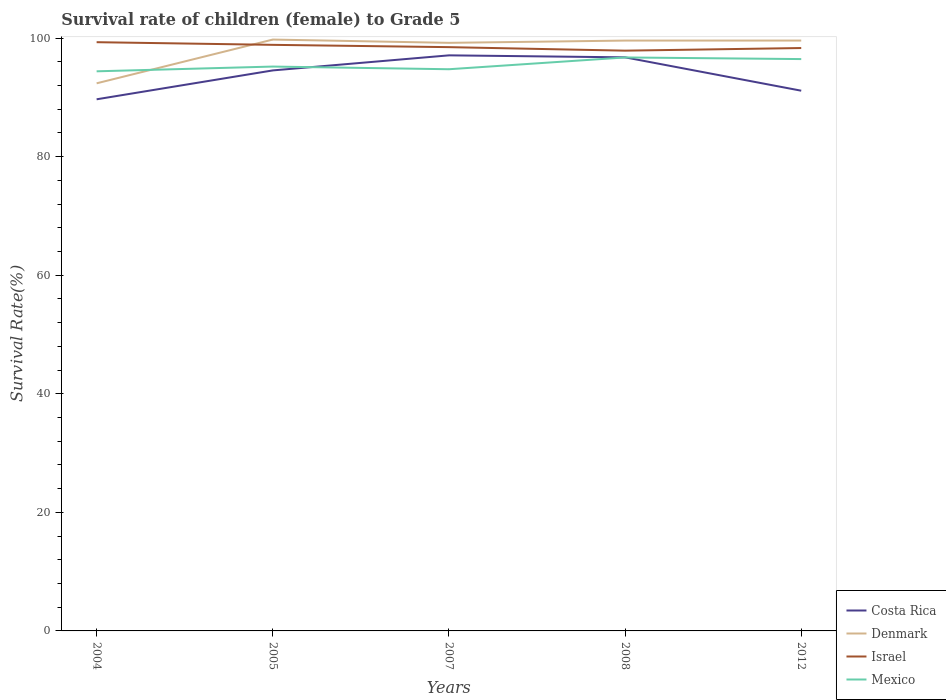How many different coloured lines are there?
Your answer should be compact. 4. Across all years, what is the maximum survival rate of female children to grade 5 in Israel?
Your response must be concise. 97.89. What is the total survival rate of female children to grade 5 in Israel in the graph?
Offer a very short reply. 0.59. What is the difference between the highest and the second highest survival rate of female children to grade 5 in Mexico?
Offer a terse response. 2.34. What is the difference between the highest and the lowest survival rate of female children to grade 5 in Costa Rica?
Give a very brief answer. 3. Is the survival rate of female children to grade 5 in Denmark strictly greater than the survival rate of female children to grade 5 in Costa Rica over the years?
Give a very brief answer. No. What is the difference between two consecutive major ticks on the Y-axis?
Your response must be concise. 20. Are the values on the major ticks of Y-axis written in scientific E-notation?
Make the answer very short. No. Does the graph contain any zero values?
Your response must be concise. No. Where does the legend appear in the graph?
Your answer should be very brief. Bottom right. How are the legend labels stacked?
Make the answer very short. Vertical. What is the title of the graph?
Your response must be concise. Survival rate of children (female) to Grade 5. Does "Uganda" appear as one of the legend labels in the graph?
Offer a terse response. No. What is the label or title of the X-axis?
Your response must be concise. Years. What is the label or title of the Y-axis?
Your answer should be compact. Survival Rate(%). What is the Survival Rate(%) of Costa Rica in 2004?
Provide a short and direct response. 89.68. What is the Survival Rate(%) in Denmark in 2004?
Give a very brief answer. 92.38. What is the Survival Rate(%) in Israel in 2004?
Your answer should be very brief. 99.31. What is the Survival Rate(%) in Mexico in 2004?
Your answer should be compact. 94.4. What is the Survival Rate(%) in Costa Rica in 2005?
Offer a very short reply. 94.55. What is the Survival Rate(%) in Denmark in 2005?
Keep it short and to the point. 99.76. What is the Survival Rate(%) of Israel in 2005?
Keep it short and to the point. 98.87. What is the Survival Rate(%) of Mexico in 2005?
Give a very brief answer. 95.2. What is the Survival Rate(%) in Costa Rica in 2007?
Give a very brief answer. 97.09. What is the Survival Rate(%) in Denmark in 2007?
Your answer should be very brief. 99.2. What is the Survival Rate(%) in Israel in 2007?
Your answer should be compact. 98.48. What is the Survival Rate(%) in Mexico in 2007?
Offer a terse response. 94.75. What is the Survival Rate(%) in Costa Rica in 2008?
Your answer should be very brief. 96.76. What is the Survival Rate(%) of Denmark in 2008?
Keep it short and to the point. 99.59. What is the Survival Rate(%) of Israel in 2008?
Provide a short and direct response. 97.89. What is the Survival Rate(%) of Mexico in 2008?
Keep it short and to the point. 96.74. What is the Survival Rate(%) in Costa Rica in 2012?
Offer a terse response. 91.13. What is the Survival Rate(%) of Denmark in 2012?
Your answer should be very brief. 99.59. What is the Survival Rate(%) in Israel in 2012?
Offer a terse response. 98.33. What is the Survival Rate(%) in Mexico in 2012?
Keep it short and to the point. 96.47. Across all years, what is the maximum Survival Rate(%) of Costa Rica?
Your answer should be very brief. 97.09. Across all years, what is the maximum Survival Rate(%) of Denmark?
Make the answer very short. 99.76. Across all years, what is the maximum Survival Rate(%) of Israel?
Give a very brief answer. 99.31. Across all years, what is the maximum Survival Rate(%) in Mexico?
Make the answer very short. 96.74. Across all years, what is the minimum Survival Rate(%) in Costa Rica?
Make the answer very short. 89.68. Across all years, what is the minimum Survival Rate(%) in Denmark?
Give a very brief answer. 92.38. Across all years, what is the minimum Survival Rate(%) in Israel?
Offer a very short reply. 97.89. Across all years, what is the minimum Survival Rate(%) of Mexico?
Your answer should be compact. 94.4. What is the total Survival Rate(%) in Costa Rica in the graph?
Provide a short and direct response. 469.22. What is the total Survival Rate(%) in Denmark in the graph?
Make the answer very short. 490.51. What is the total Survival Rate(%) of Israel in the graph?
Offer a terse response. 492.88. What is the total Survival Rate(%) of Mexico in the graph?
Ensure brevity in your answer.  477.56. What is the difference between the Survival Rate(%) of Costa Rica in 2004 and that in 2005?
Ensure brevity in your answer.  -4.87. What is the difference between the Survival Rate(%) in Denmark in 2004 and that in 2005?
Your answer should be very brief. -7.38. What is the difference between the Survival Rate(%) of Israel in 2004 and that in 2005?
Ensure brevity in your answer.  0.45. What is the difference between the Survival Rate(%) in Mexico in 2004 and that in 2005?
Give a very brief answer. -0.8. What is the difference between the Survival Rate(%) of Costa Rica in 2004 and that in 2007?
Make the answer very short. -7.41. What is the difference between the Survival Rate(%) in Denmark in 2004 and that in 2007?
Offer a very short reply. -6.83. What is the difference between the Survival Rate(%) of Israel in 2004 and that in 2007?
Give a very brief answer. 0.83. What is the difference between the Survival Rate(%) of Mexico in 2004 and that in 2007?
Provide a succinct answer. -0.35. What is the difference between the Survival Rate(%) of Costa Rica in 2004 and that in 2008?
Offer a very short reply. -7.08. What is the difference between the Survival Rate(%) in Denmark in 2004 and that in 2008?
Give a very brief answer. -7.21. What is the difference between the Survival Rate(%) in Israel in 2004 and that in 2008?
Make the answer very short. 1.43. What is the difference between the Survival Rate(%) of Mexico in 2004 and that in 2008?
Offer a terse response. -2.34. What is the difference between the Survival Rate(%) in Costa Rica in 2004 and that in 2012?
Your response must be concise. -1.45. What is the difference between the Survival Rate(%) of Denmark in 2004 and that in 2012?
Make the answer very short. -7.21. What is the difference between the Survival Rate(%) in Israel in 2004 and that in 2012?
Keep it short and to the point. 0.99. What is the difference between the Survival Rate(%) of Mexico in 2004 and that in 2012?
Provide a short and direct response. -2.06. What is the difference between the Survival Rate(%) of Costa Rica in 2005 and that in 2007?
Offer a terse response. -2.54. What is the difference between the Survival Rate(%) of Denmark in 2005 and that in 2007?
Ensure brevity in your answer.  0.55. What is the difference between the Survival Rate(%) in Israel in 2005 and that in 2007?
Your answer should be very brief. 0.39. What is the difference between the Survival Rate(%) of Mexico in 2005 and that in 2007?
Offer a terse response. 0.45. What is the difference between the Survival Rate(%) of Costa Rica in 2005 and that in 2008?
Your answer should be compact. -2.2. What is the difference between the Survival Rate(%) in Denmark in 2005 and that in 2008?
Offer a very short reply. 0.17. What is the difference between the Survival Rate(%) of Israel in 2005 and that in 2008?
Offer a terse response. 0.98. What is the difference between the Survival Rate(%) of Mexico in 2005 and that in 2008?
Make the answer very short. -1.54. What is the difference between the Survival Rate(%) of Costa Rica in 2005 and that in 2012?
Your response must be concise. 3.42. What is the difference between the Survival Rate(%) in Denmark in 2005 and that in 2012?
Provide a succinct answer. 0.17. What is the difference between the Survival Rate(%) in Israel in 2005 and that in 2012?
Your response must be concise. 0.54. What is the difference between the Survival Rate(%) in Mexico in 2005 and that in 2012?
Offer a terse response. -1.26. What is the difference between the Survival Rate(%) of Costa Rica in 2007 and that in 2008?
Give a very brief answer. 0.34. What is the difference between the Survival Rate(%) of Denmark in 2007 and that in 2008?
Provide a succinct answer. -0.38. What is the difference between the Survival Rate(%) of Israel in 2007 and that in 2008?
Your answer should be compact. 0.59. What is the difference between the Survival Rate(%) in Mexico in 2007 and that in 2008?
Keep it short and to the point. -1.99. What is the difference between the Survival Rate(%) of Costa Rica in 2007 and that in 2012?
Give a very brief answer. 5.96. What is the difference between the Survival Rate(%) of Denmark in 2007 and that in 2012?
Make the answer very short. -0.38. What is the difference between the Survival Rate(%) of Israel in 2007 and that in 2012?
Offer a very short reply. 0.15. What is the difference between the Survival Rate(%) in Mexico in 2007 and that in 2012?
Offer a very short reply. -1.71. What is the difference between the Survival Rate(%) in Costa Rica in 2008 and that in 2012?
Make the answer very short. 5.63. What is the difference between the Survival Rate(%) of Denmark in 2008 and that in 2012?
Provide a short and direct response. -0. What is the difference between the Survival Rate(%) in Israel in 2008 and that in 2012?
Your answer should be compact. -0.44. What is the difference between the Survival Rate(%) of Mexico in 2008 and that in 2012?
Offer a terse response. 0.27. What is the difference between the Survival Rate(%) of Costa Rica in 2004 and the Survival Rate(%) of Denmark in 2005?
Your answer should be very brief. -10.08. What is the difference between the Survival Rate(%) in Costa Rica in 2004 and the Survival Rate(%) in Israel in 2005?
Ensure brevity in your answer.  -9.19. What is the difference between the Survival Rate(%) in Costa Rica in 2004 and the Survival Rate(%) in Mexico in 2005?
Ensure brevity in your answer.  -5.52. What is the difference between the Survival Rate(%) in Denmark in 2004 and the Survival Rate(%) in Israel in 2005?
Provide a succinct answer. -6.49. What is the difference between the Survival Rate(%) of Denmark in 2004 and the Survival Rate(%) of Mexico in 2005?
Provide a short and direct response. -2.83. What is the difference between the Survival Rate(%) in Israel in 2004 and the Survival Rate(%) in Mexico in 2005?
Your answer should be very brief. 4.11. What is the difference between the Survival Rate(%) in Costa Rica in 2004 and the Survival Rate(%) in Denmark in 2007?
Ensure brevity in your answer.  -9.52. What is the difference between the Survival Rate(%) in Costa Rica in 2004 and the Survival Rate(%) in Israel in 2007?
Your answer should be compact. -8.8. What is the difference between the Survival Rate(%) of Costa Rica in 2004 and the Survival Rate(%) of Mexico in 2007?
Provide a short and direct response. -5.07. What is the difference between the Survival Rate(%) of Denmark in 2004 and the Survival Rate(%) of Israel in 2007?
Your answer should be very brief. -6.1. What is the difference between the Survival Rate(%) of Denmark in 2004 and the Survival Rate(%) of Mexico in 2007?
Make the answer very short. -2.38. What is the difference between the Survival Rate(%) in Israel in 2004 and the Survival Rate(%) in Mexico in 2007?
Your response must be concise. 4.56. What is the difference between the Survival Rate(%) of Costa Rica in 2004 and the Survival Rate(%) of Denmark in 2008?
Offer a very short reply. -9.9. What is the difference between the Survival Rate(%) of Costa Rica in 2004 and the Survival Rate(%) of Israel in 2008?
Make the answer very short. -8.21. What is the difference between the Survival Rate(%) in Costa Rica in 2004 and the Survival Rate(%) in Mexico in 2008?
Give a very brief answer. -7.06. What is the difference between the Survival Rate(%) of Denmark in 2004 and the Survival Rate(%) of Israel in 2008?
Provide a succinct answer. -5.51. What is the difference between the Survival Rate(%) in Denmark in 2004 and the Survival Rate(%) in Mexico in 2008?
Keep it short and to the point. -4.36. What is the difference between the Survival Rate(%) of Israel in 2004 and the Survival Rate(%) of Mexico in 2008?
Ensure brevity in your answer.  2.57. What is the difference between the Survival Rate(%) of Costa Rica in 2004 and the Survival Rate(%) of Denmark in 2012?
Your response must be concise. -9.91. What is the difference between the Survival Rate(%) of Costa Rica in 2004 and the Survival Rate(%) of Israel in 2012?
Your answer should be very brief. -8.65. What is the difference between the Survival Rate(%) in Costa Rica in 2004 and the Survival Rate(%) in Mexico in 2012?
Offer a terse response. -6.78. What is the difference between the Survival Rate(%) of Denmark in 2004 and the Survival Rate(%) of Israel in 2012?
Provide a succinct answer. -5.95. What is the difference between the Survival Rate(%) in Denmark in 2004 and the Survival Rate(%) in Mexico in 2012?
Offer a very short reply. -4.09. What is the difference between the Survival Rate(%) in Israel in 2004 and the Survival Rate(%) in Mexico in 2012?
Keep it short and to the point. 2.85. What is the difference between the Survival Rate(%) of Costa Rica in 2005 and the Survival Rate(%) of Denmark in 2007?
Provide a short and direct response. -4.65. What is the difference between the Survival Rate(%) of Costa Rica in 2005 and the Survival Rate(%) of Israel in 2007?
Your answer should be very brief. -3.93. What is the difference between the Survival Rate(%) in Costa Rica in 2005 and the Survival Rate(%) in Mexico in 2007?
Your response must be concise. -0.2. What is the difference between the Survival Rate(%) in Denmark in 2005 and the Survival Rate(%) in Israel in 2007?
Provide a short and direct response. 1.28. What is the difference between the Survival Rate(%) of Denmark in 2005 and the Survival Rate(%) of Mexico in 2007?
Your answer should be very brief. 5.01. What is the difference between the Survival Rate(%) of Israel in 2005 and the Survival Rate(%) of Mexico in 2007?
Offer a very short reply. 4.11. What is the difference between the Survival Rate(%) in Costa Rica in 2005 and the Survival Rate(%) in Denmark in 2008?
Offer a very short reply. -5.03. What is the difference between the Survival Rate(%) of Costa Rica in 2005 and the Survival Rate(%) of Mexico in 2008?
Your response must be concise. -2.19. What is the difference between the Survival Rate(%) in Denmark in 2005 and the Survival Rate(%) in Israel in 2008?
Give a very brief answer. 1.87. What is the difference between the Survival Rate(%) of Denmark in 2005 and the Survival Rate(%) of Mexico in 2008?
Make the answer very short. 3.02. What is the difference between the Survival Rate(%) of Israel in 2005 and the Survival Rate(%) of Mexico in 2008?
Provide a short and direct response. 2.13. What is the difference between the Survival Rate(%) in Costa Rica in 2005 and the Survival Rate(%) in Denmark in 2012?
Offer a terse response. -5.03. What is the difference between the Survival Rate(%) of Costa Rica in 2005 and the Survival Rate(%) of Israel in 2012?
Give a very brief answer. -3.77. What is the difference between the Survival Rate(%) in Costa Rica in 2005 and the Survival Rate(%) in Mexico in 2012?
Provide a short and direct response. -1.91. What is the difference between the Survival Rate(%) in Denmark in 2005 and the Survival Rate(%) in Israel in 2012?
Offer a terse response. 1.43. What is the difference between the Survival Rate(%) of Denmark in 2005 and the Survival Rate(%) of Mexico in 2012?
Offer a terse response. 3.29. What is the difference between the Survival Rate(%) of Israel in 2005 and the Survival Rate(%) of Mexico in 2012?
Offer a terse response. 2.4. What is the difference between the Survival Rate(%) in Costa Rica in 2007 and the Survival Rate(%) in Denmark in 2008?
Offer a very short reply. -2.49. What is the difference between the Survival Rate(%) of Costa Rica in 2007 and the Survival Rate(%) of Israel in 2008?
Make the answer very short. -0.79. What is the difference between the Survival Rate(%) of Costa Rica in 2007 and the Survival Rate(%) of Mexico in 2008?
Give a very brief answer. 0.35. What is the difference between the Survival Rate(%) in Denmark in 2007 and the Survival Rate(%) in Israel in 2008?
Ensure brevity in your answer.  1.32. What is the difference between the Survival Rate(%) in Denmark in 2007 and the Survival Rate(%) in Mexico in 2008?
Make the answer very short. 2.46. What is the difference between the Survival Rate(%) of Israel in 2007 and the Survival Rate(%) of Mexico in 2008?
Keep it short and to the point. 1.74. What is the difference between the Survival Rate(%) of Costa Rica in 2007 and the Survival Rate(%) of Denmark in 2012?
Keep it short and to the point. -2.49. What is the difference between the Survival Rate(%) in Costa Rica in 2007 and the Survival Rate(%) in Israel in 2012?
Make the answer very short. -1.23. What is the difference between the Survival Rate(%) of Costa Rica in 2007 and the Survival Rate(%) of Mexico in 2012?
Your answer should be very brief. 0.63. What is the difference between the Survival Rate(%) of Denmark in 2007 and the Survival Rate(%) of Israel in 2012?
Make the answer very short. 0.88. What is the difference between the Survival Rate(%) of Denmark in 2007 and the Survival Rate(%) of Mexico in 2012?
Provide a succinct answer. 2.74. What is the difference between the Survival Rate(%) in Israel in 2007 and the Survival Rate(%) in Mexico in 2012?
Your answer should be very brief. 2.01. What is the difference between the Survival Rate(%) in Costa Rica in 2008 and the Survival Rate(%) in Denmark in 2012?
Offer a very short reply. -2.83. What is the difference between the Survival Rate(%) in Costa Rica in 2008 and the Survival Rate(%) in Israel in 2012?
Give a very brief answer. -1.57. What is the difference between the Survival Rate(%) of Costa Rica in 2008 and the Survival Rate(%) of Mexico in 2012?
Keep it short and to the point. 0.29. What is the difference between the Survival Rate(%) of Denmark in 2008 and the Survival Rate(%) of Israel in 2012?
Make the answer very short. 1.26. What is the difference between the Survival Rate(%) of Denmark in 2008 and the Survival Rate(%) of Mexico in 2012?
Your answer should be very brief. 3.12. What is the difference between the Survival Rate(%) of Israel in 2008 and the Survival Rate(%) of Mexico in 2012?
Offer a very short reply. 1.42. What is the average Survival Rate(%) in Costa Rica per year?
Your answer should be compact. 93.84. What is the average Survival Rate(%) of Denmark per year?
Keep it short and to the point. 98.1. What is the average Survival Rate(%) in Israel per year?
Offer a terse response. 98.58. What is the average Survival Rate(%) of Mexico per year?
Keep it short and to the point. 95.51. In the year 2004, what is the difference between the Survival Rate(%) of Costa Rica and Survival Rate(%) of Denmark?
Ensure brevity in your answer.  -2.7. In the year 2004, what is the difference between the Survival Rate(%) in Costa Rica and Survival Rate(%) in Israel?
Your answer should be compact. -9.63. In the year 2004, what is the difference between the Survival Rate(%) in Costa Rica and Survival Rate(%) in Mexico?
Give a very brief answer. -4.72. In the year 2004, what is the difference between the Survival Rate(%) of Denmark and Survival Rate(%) of Israel?
Offer a terse response. -6.94. In the year 2004, what is the difference between the Survival Rate(%) in Denmark and Survival Rate(%) in Mexico?
Make the answer very short. -2.02. In the year 2004, what is the difference between the Survival Rate(%) in Israel and Survival Rate(%) in Mexico?
Make the answer very short. 4.91. In the year 2005, what is the difference between the Survival Rate(%) of Costa Rica and Survival Rate(%) of Denmark?
Keep it short and to the point. -5.2. In the year 2005, what is the difference between the Survival Rate(%) of Costa Rica and Survival Rate(%) of Israel?
Make the answer very short. -4.31. In the year 2005, what is the difference between the Survival Rate(%) of Costa Rica and Survival Rate(%) of Mexico?
Provide a succinct answer. -0.65. In the year 2005, what is the difference between the Survival Rate(%) in Denmark and Survival Rate(%) in Israel?
Keep it short and to the point. 0.89. In the year 2005, what is the difference between the Survival Rate(%) of Denmark and Survival Rate(%) of Mexico?
Make the answer very short. 4.56. In the year 2005, what is the difference between the Survival Rate(%) of Israel and Survival Rate(%) of Mexico?
Make the answer very short. 3.66. In the year 2007, what is the difference between the Survival Rate(%) in Costa Rica and Survival Rate(%) in Denmark?
Provide a succinct answer. -2.11. In the year 2007, what is the difference between the Survival Rate(%) in Costa Rica and Survival Rate(%) in Israel?
Give a very brief answer. -1.39. In the year 2007, what is the difference between the Survival Rate(%) of Costa Rica and Survival Rate(%) of Mexico?
Your response must be concise. 2.34. In the year 2007, what is the difference between the Survival Rate(%) in Denmark and Survival Rate(%) in Israel?
Ensure brevity in your answer.  0.72. In the year 2007, what is the difference between the Survival Rate(%) in Denmark and Survival Rate(%) in Mexico?
Give a very brief answer. 4.45. In the year 2007, what is the difference between the Survival Rate(%) of Israel and Survival Rate(%) of Mexico?
Make the answer very short. 3.73. In the year 2008, what is the difference between the Survival Rate(%) of Costa Rica and Survival Rate(%) of Denmark?
Provide a succinct answer. -2.83. In the year 2008, what is the difference between the Survival Rate(%) of Costa Rica and Survival Rate(%) of Israel?
Your answer should be compact. -1.13. In the year 2008, what is the difference between the Survival Rate(%) of Costa Rica and Survival Rate(%) of Mexico?
Provide a succinct answer. 0.02. In the year 2008, what is the difference between the Survival Rate(%) of Denmark and Survival Rate(%) of Israel?
Provide a succinct answer. 1.7. In the year 2008, what is the difference between the Survival Rate(%) in Denmark and Survival Rate(%) in Mexico?
Give a very brief answer. 2.85. In the year 2008, what is the difference between the Survival Rate(%) of Israel and Survival Rate(%) of Mexico?
Your answer should be very brief. 1.15. In the year 2012, what is the difference between the Survival Rate(%) of Costa Rica and Survival Rate(%) of Denmark?
Make the answer very short. -8.46. In the year 2012, what is the difference between the Survival Rate(%) in Costa Rica and Survival Rate(%) in Israel?
Provide a succinct answer. -7.2. In the year 2012, what is the difference between the Survival Rate(%) in Costa Rica and Survival Rate(%) in Mexico?
Offer a very short reply. -5.34. In the year 2012, what is the difference between the Survival Rate(%) in Denmark and Survival Rate(%) in Israel?
Your response must be concise. 1.26. In the year 2012, what is the difference between the Survival Rate(%) in Denmark and Survival Rate(%) in Mexico?
Make the answer very short. 3.12. In the year 2012, what is the difference between the Survival Rate(%) in Israel and Survival Rate(%) in Mexico?
Your response must be concise. 1.86. What is the ratio of the Survival Rate(%) in Costa Rica in 2004 to that in 2005?
Keep it short and to the point. 0.95. What is the ratio of the Survival Rate(%) in Denmark in 2004 to that in 2005?
Make the answer very short. 0.93. What is the ratio of the Survival Rate(%) of Mexico in 2004 to that in 2005?
Your answer should be compact. 0.99. What is the ratio of the Survival Rate(%) of Costa Rica in 2004 to that in 2007?
Keep it short and to the point. 0.92. What is the ratio of the Survival Rate(%) of Denmark in 2004 to that in 2007?
Your answer should be compact. 0.93. What is the ratio of the Survival Rate(%) of Israel in 2004 to that in 2007?
Offer a terse response. 1.01. What is the ratio of the Survival Rate(%) in Mexico in 2004 to that in 2007?
Your response must be concise. 1. What is the ratio of the Survival Rate(%) in Costa Rica in 2004 to that in 2008?
Your answer should be compact. 0.93. What is the ratio of the Survival Rate(%) of Denmark in 2004 to that in 2008?
Your answer should be compact. 0.93. What is the ratio of the Survival Rate(%) in Israel in 2004 to that in 2008?
Give a very brief answer. 1.01. What is the ratio of the Survival Rate(%) of Mexico in 2004 to that in 2008?
Keep it short and to the point. 0.98. What is the ratio of the Survival Rate(%) in Costa Rica in 2004 to that in 2012?
Provide a succinct answer. 0.98. What is the ratio of the Survival Rate(%) of Denmark in 2004 to that in 2012?
Provide a short and direct response. 0.93. What is the ratio of the Survival Rate(%) in Mexico in 2004 to that in 2012?
Keep it short and to the point. 0.98. What is the ratio of the Survival Rate(%) of Costa Rica in 2005 to that in 2007?
Keep it short and to the point. 0.97. What is the ratio of the Survival Rate(%) in Denmark in 2005 to that in 2007?
Offer a very short reply. 1.01. What is the ratio of the Survival Rate(%) in Mexico in 2005 to that in 2007?
Offer a terse response. 1. What is the ratio of the Survival Rate(%) of Costa Rica in 2005 to that in 2008?
Provide a succinct answer. 0.98. What is the ratio of the Survival Rate(%) in Denmark in 2005 to that in 2008?
Make the answer very short. 1. What is the ratio of the Survival Rate(%) of Israel in 2005 to that in 2008?
Offer a terse response. 1.01. What is the ratio of the Survival Rate(%) in Mexico in 2005 to that in 2008?
Provide a succinct answer. 0.98. What is the ratio of the Survival Rate(%) in Costa Rica in 2005 to that in 2012?
Your answer should be compact. 1.04. What is the ratio of the Survival Rate(%) of Denmark in 2005 to that in 2012?
Provide a succinct answer. 1. What is the ratio of the Survival Rate(%) of Israel in 2005 to that in 2012?
Your response must be concise. 1.01. What is the ratio of the Survival Rate(%) of Mexico in 2005 to that in 2012?
Offer a very short reply. 0.99. What is the ratio of the Survival Rate(%) in Denmark in 2007 to that in 2008?
Provide a succinct answer. 1. What is the ratio of the Survival Rate(%) of Mexico in 2007 to that in 2008?
Keep it short and to the point. 0.98. What is the ratio of the Survival Rate(%) in Costa Rica in 2007 to that in 2012?
Your answer should be compact. 1.07. What is the ratio of the Survival Rate(%) of Mexico in 2007 to that in 2012?
Provide a succinct answer. 0.98. What is the ratio of the Survival Rate(%) of Costa Rica in 2008 to that in 2012?
Provide a succinct answer. 1.06. What is the ratio of the Survival Rate(%) of Denmark in 2008 to that in 2012?
Keep it short and to the point. 1. What is the difference between the highest and the second highest Survival Rate(%) in Costa Rica?
Provide a short and direct response. 0.34. What is the difference between the highest and the second highest Survival Rate(%) in Denmark?
Your answer should be very brief. 0.17. What is the difference between the highest and the second highest Survival Rate(%) of Israel?
Keep it short and to the point. 0.45. What is the difference between the highest and the second highest Survival Rate(%) in Mexico?
Your response must be concise. 0.27. What is the difference between the highest and the lowest Survival Rate(%) of Costa Rica?
Offer a terse response. 7.41. What is the difference between the highest and the lowest Survival Rate(%) in Denmark?
Offer a terse response. 7.38. What is the difference between the highest and the lowest Survival Rate(%) in Israel?
Keep it short and to the point. 1.43. What is the difference between the highest and the lowest Survival Rate(%) in Mexico?
Provide a short and direct response. 2.34. 